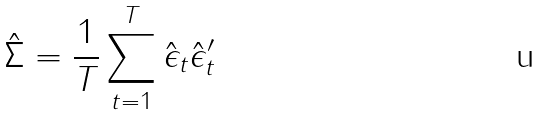<formula> <loc_0><loc_0><loc_500><loc_500>\hat { \Sigma } = \frac { 1 } { T } \sum _ { t = 1 } ^ { T } \hat { \epsilon } _ { t } \hat { \epsilon } _ { t } ^ { \prime }</formula> 